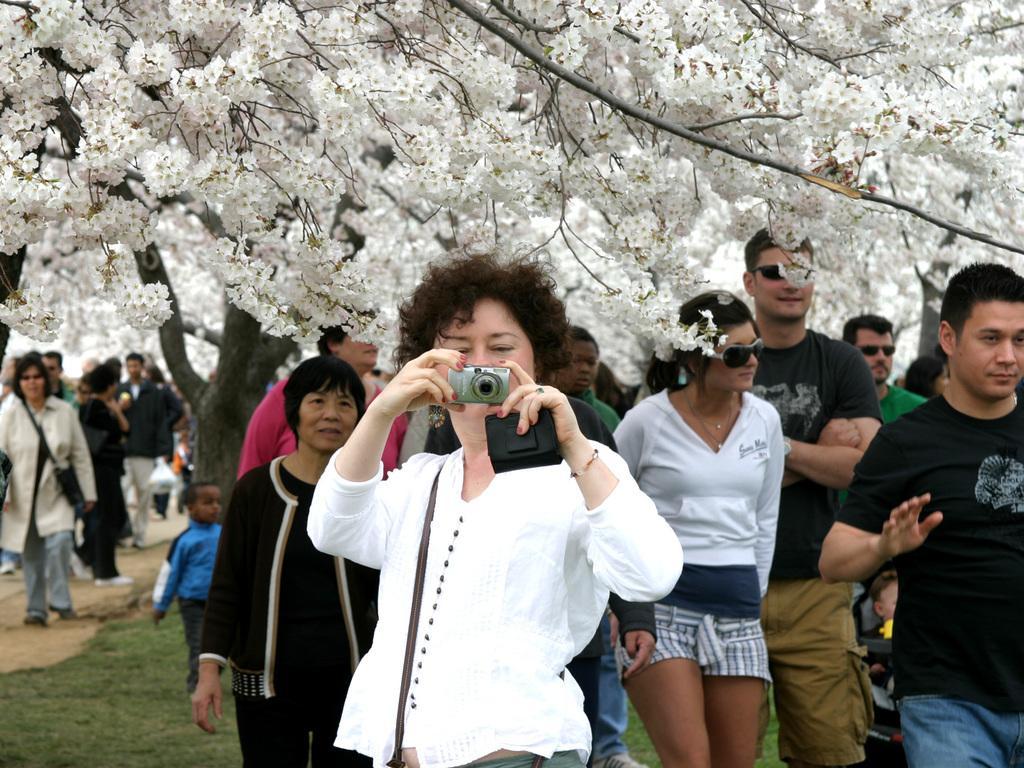Please provide a concise description of this image. In this image, in the middle there is a woman, she is holding a camera. In the middle there are many people, they are walking. At the bottom there is grassland. In the background there are trees, flowers, stems. 